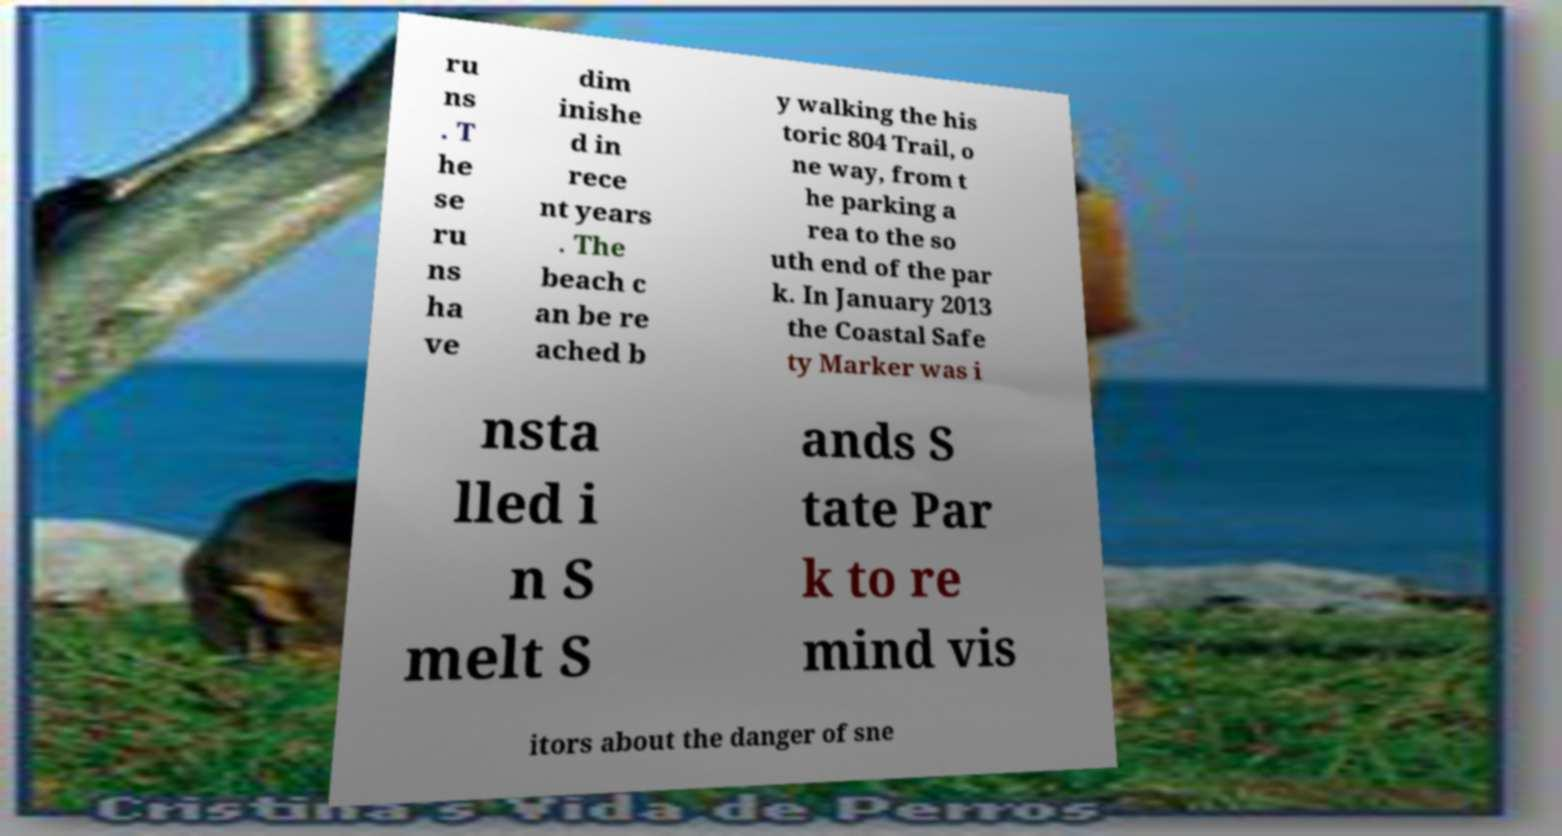For documentation purposes, I need the text within this image transcribed. Could you provide that? ru ns . T he se ru ns ha ve dim inishe d in rece nt years . The beach c an be re ached b y walking the his toric 804 Trail, o ne way, from t he parking a rea to the so uth end of the par k. In January 2013 the Coastal Safe ty Marker was i nsta lled i n S melt S ands S tate Par k to re mind vis itors about the danger of sne 